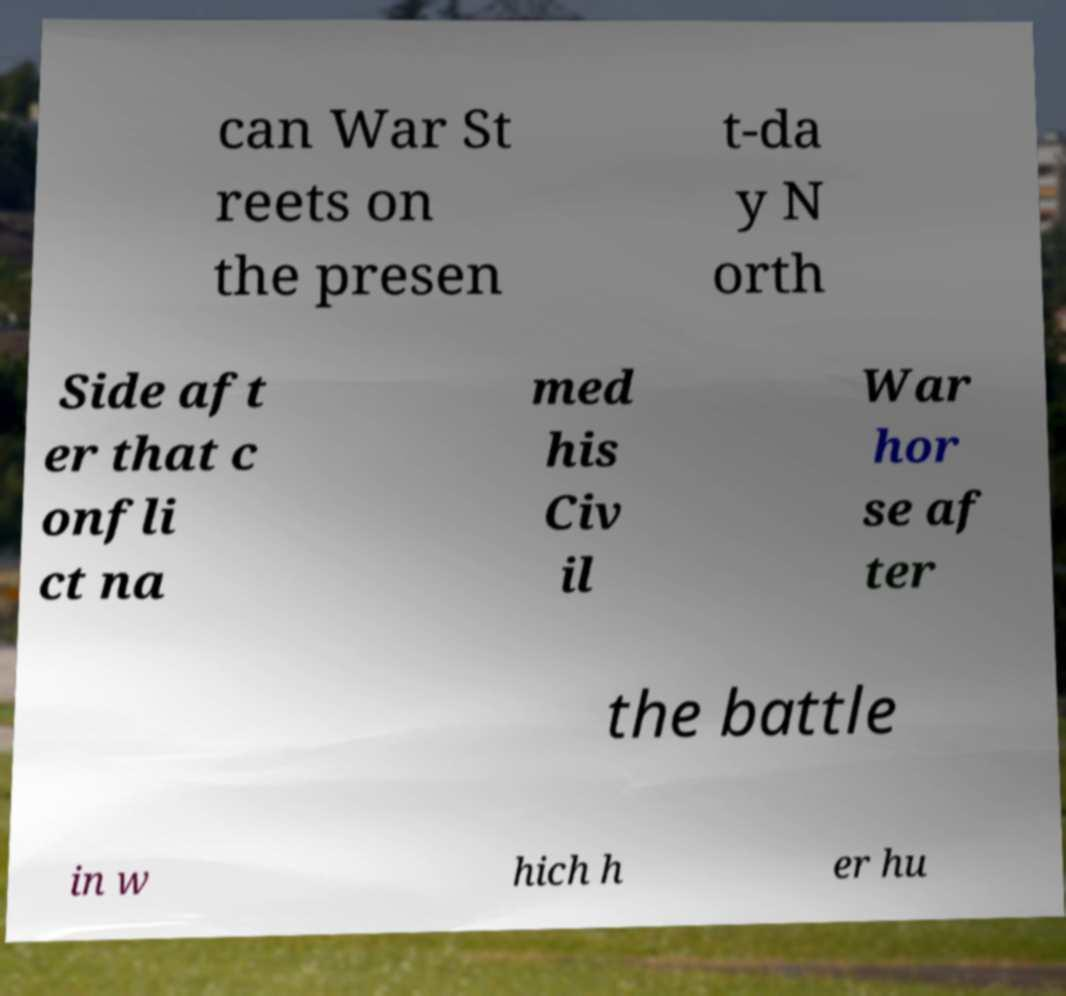I need the written content from this picture converted into text. Can you do that? can War St reets on the presen t-da y N orth Side aft er that c onfli ct na med his Civ il War hor se af ter the battle in w hich h er hu 